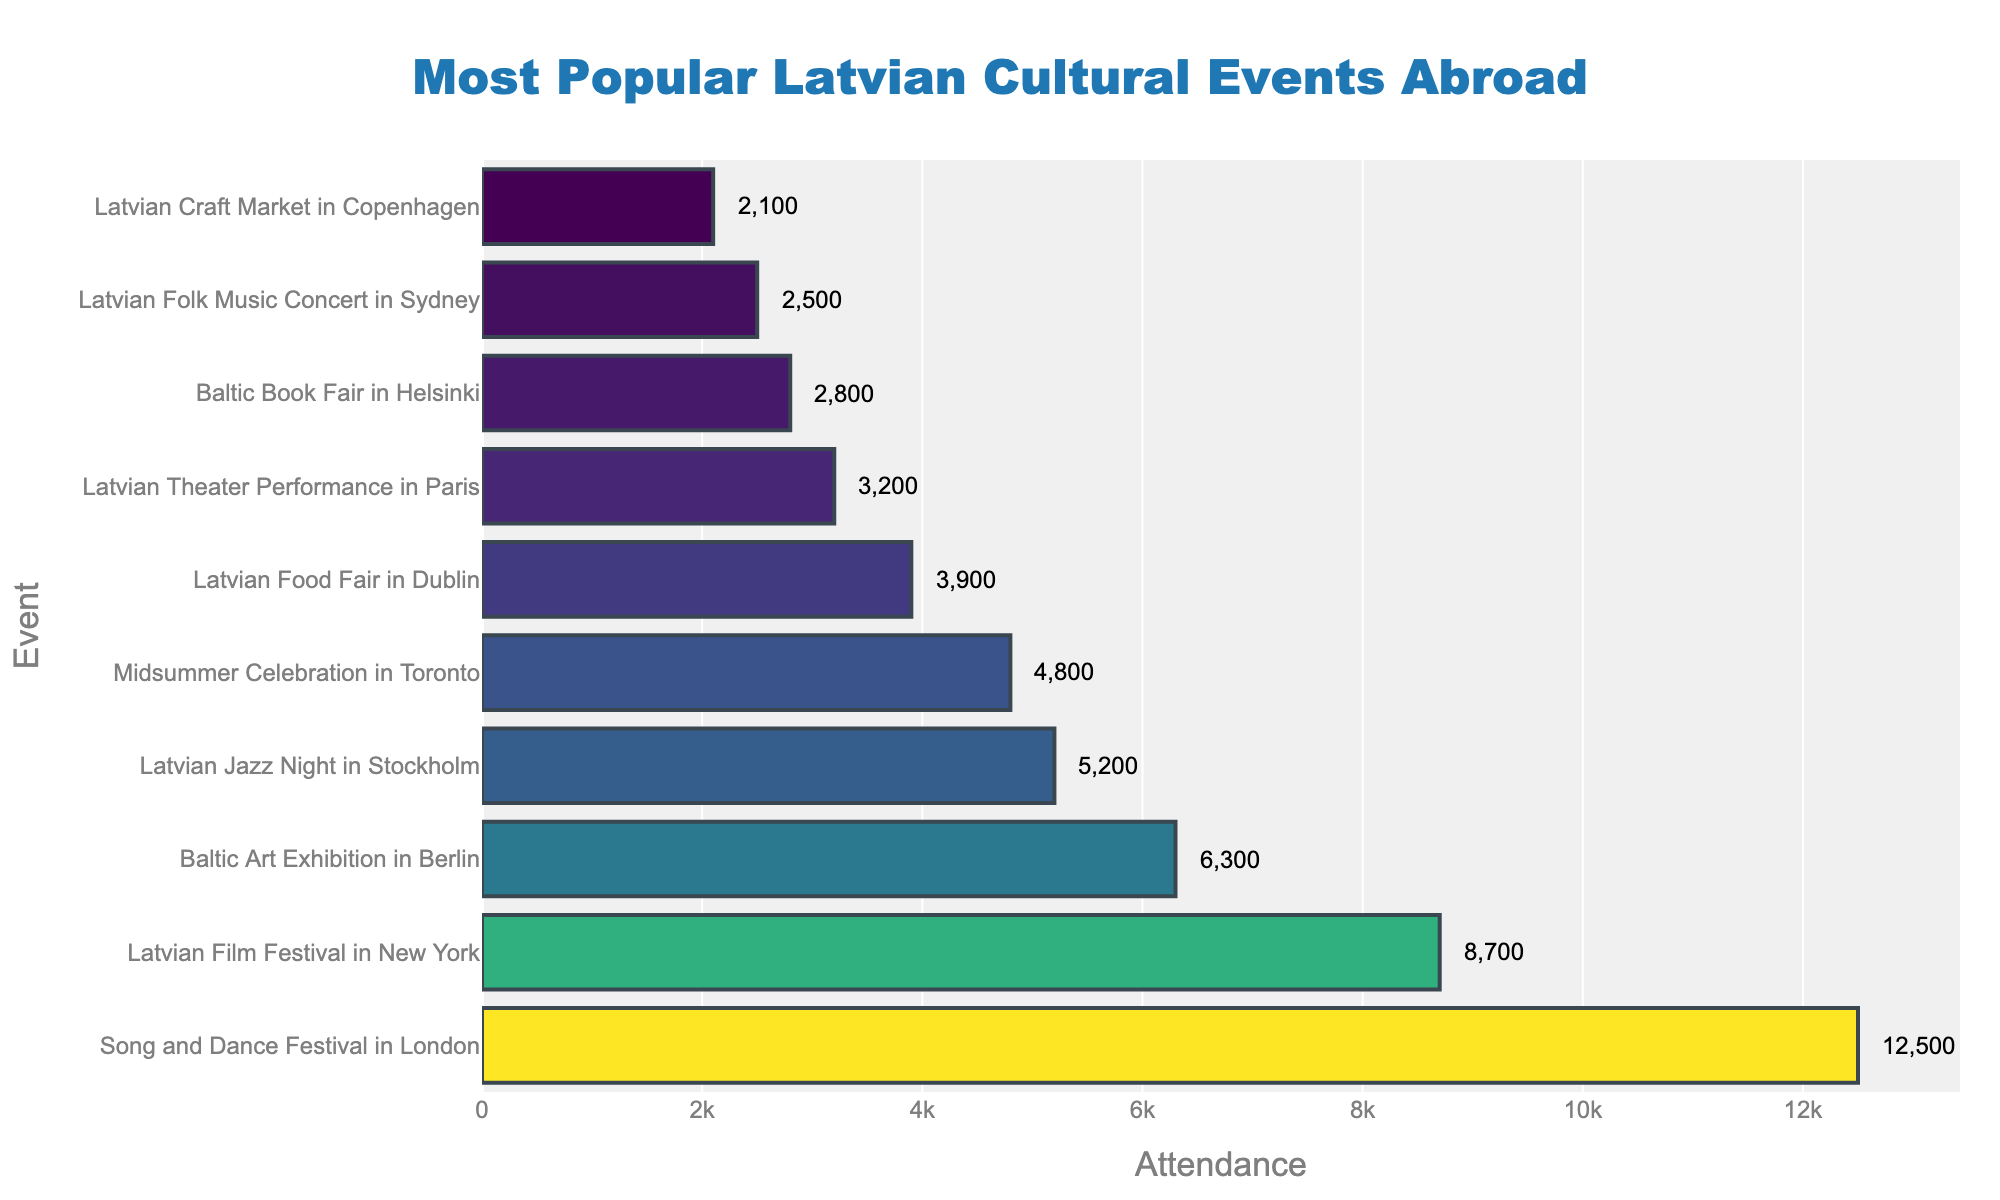Which event has the highest attendance? The event with the highest attendance can be identified by looking for the longest bar on the chart. The longest bar represents the Song and Dance Festival in London with an attendance of 12,500.
Answer: Song and Dance Festival in London How many total people attended the Latvian Film Festival in New York and the Midsummer Celebration in Toronto combined? To find the total attendance, add the attendance of the Latvian Film Festival in New York (8,700) and the attendance of the Midsummer Celebration in Toronto (4,800). This results in 8,700 + 4,800 = 13,500.
Answer: 13,500 Is the attendance of the Baltic Art Exhibition in Berlin higher than that of the Latvian Jazz Night in Stockholm? To determine if the Baltic Art Exhibition in Berlin has higher attendance, compare the attendance numbers: 6,300 for the Baltic Art Exhibition and 5,200 for the Latvian Jazz Night in Stockholm. 6,300 is greater than 5,200.
Answer: Yes What is the difference in attendance between the highest and the lowest attended events? The highest attendance is for the Song and Dance Festival in London (12,500), and the lowest is for the Latvian Craft Market in Copenhagen (2,100). Subtract the lowest from the highest: 12,500 - 2,100 = 10,400.
Answer: 10,400 Which event has the sixth highest attendance? To find the sixth highest attendance, look at the sorted list from highest to lowest. The sixth event listed is the Latvian Food Fair in Dublin with 3,900 attendees.
Answer: Latvian Food Fair in Dublin Which events have an attendance of more than 5,000? Identify the bars that extend beyond the 5,000 attendance mark, which can be seen for the Song and Dance Festival in London (12,500), Latvian Film Festival in New York (8,700), Baltic Art Exhibition in Berlin (6,300), and Latvian Jazz Night in Stockholm (5,200).
Answer: Song and Dance Festival in London, Latvian Film Festival in New York, Baltic Art Exhibition in Berlin, Latvian Jazz Night in Stockholm What is the average attendance of events with more than 5,000 attendees? First, list the attendances over 5,000: 12,500, 8,700, 6,300, and 5,200. Sum these values: 12,500 + 8,700 + 6,300 + 5,200 = 32,700. Then calculate the average: 32,700 / 4 = 8,175.
Answer: 8,175 What percentage of the total attendance does the Latvian Film Festival in New York represent? First, find the total attendance by summing all the events: 12,500 + 8,700 + 6,300 + 5,200 + 4,800 + 3,900 + 3,200 + 2,800 + 2,500 + 2,100 = 52,000. Then, divide the Latvian Film Festival in New York's attendance (8,700) by the total (52,000): 8,700 / 52,000 ≈ 0.1673. Finally, convert to a percentage: 0.1673 * 100 ≈ 16.73%.
Answer: 16.73% 